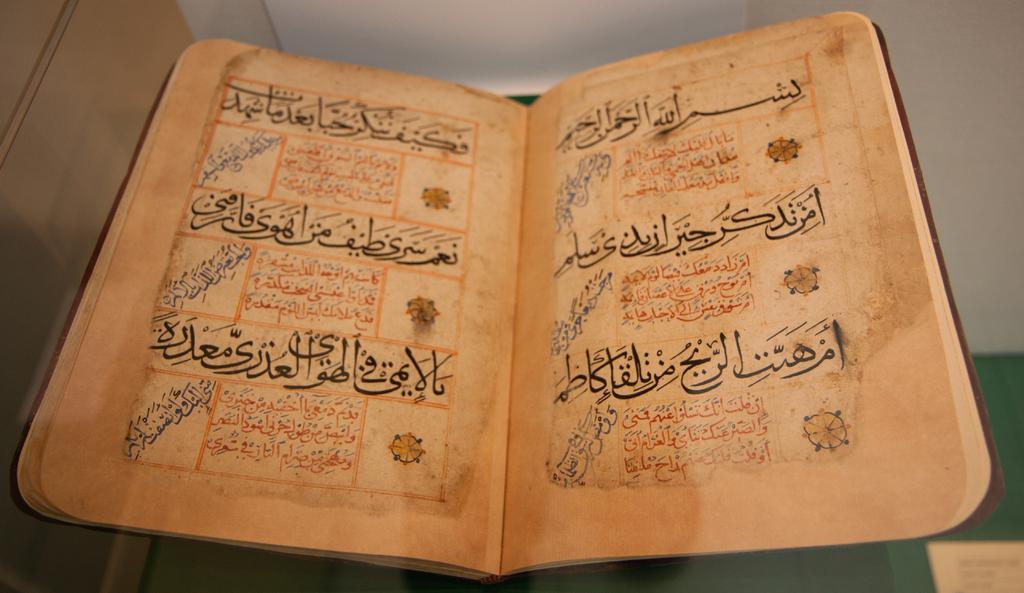Please provide a concise description of this image. In this picture I can see a book and text on the papers and I can see a white color background and It looks like a paper with some text at the bottom right corner of the picture. 